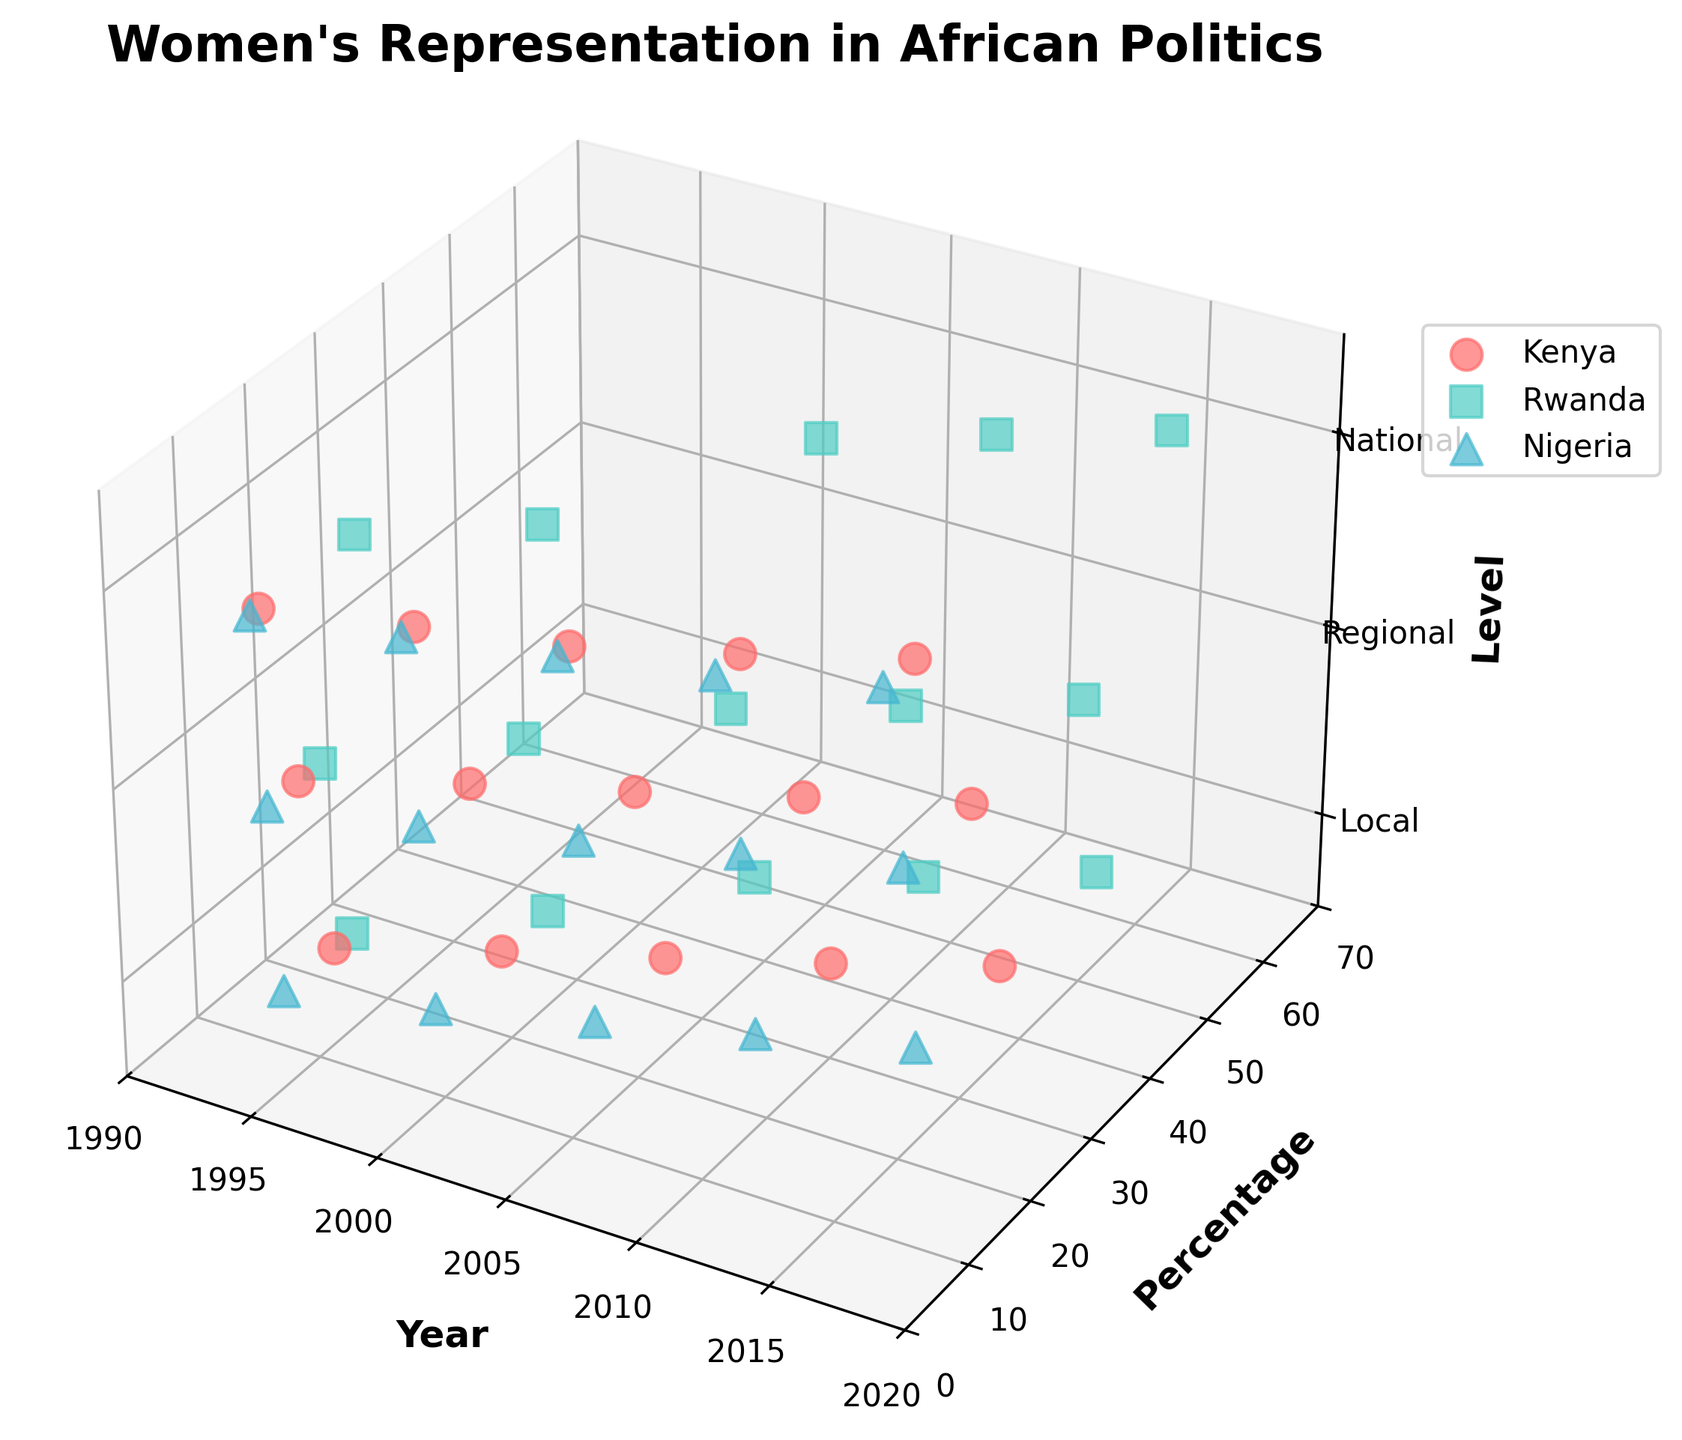What are the countries represented in the 3D scatter plot? To identify the countries in the plot, check the colors and markers, and verify each country labeled in the legend. There are three distinct countries in the legend.
Answer: Kenya, Rwanda, Nigeria What is the title of the 3D scatter plot? The title of the plot is found at the top center of the figure.
Answer: Women's Representation in African Politics Which country has the highest percentage of women's representation at the national level in 2015? Look at the data points for National level (z-axis labeled as National) from 2015 (x-axis). Find the highest percentage value (y-axis) for those points.
Answer: Rwanda How does the percentage of women's representation at the local level in Kenya change over time? Identify the data points for Kenya at the Local level (z-axis labeled as Local). Notice the trend for data points along the x-axis (Year) and y-axis (Percentage). It's an increasing trend.
Answer: Increases Compare the percentage of women's representation in Kenya at the regional level in 2000 and 2015. Which year had a higher percentage? Locate data points for Kenya at the Regional level (z-axis marked as Regional) in the years 2000 and 2015 (x-axis). Compare the y-axis values (Percentage) for these points.
Answer: 2015 Which country shows the most significant improvement in women's representation at the national level from 1995 to 2015? Examine the data points at the National level for each country, compare the percentage increase from 1995 to 2015. Calculate each change and find the largest. Rwanda's increase from 17.1% to 63.8% is the most significant.
Answer: Rwanda What's the y-axis range covered by the data points in the plot? Observe the minimum and maximum values on the y-axis. The plot clearly sets the y-axis range from 0 to 70.
Answer: 0 to 70 How does Rwanda's representation at the national level in 2005 compare with Nigeria's representation at the same level in the same year? Compare the y-axis values for the data points representing Rwanda and Nigeria in 2005 at the National level. Rwanda's point is significantly higher than Nigeria's.
Answer: Rwanda is higher Identify the trend of women's representation in local politics for Nigeria from 1995 to 2015. Observe the data points related to Nigeria at the Local level from 1995 to 2015 along the x-axis (Year) and y-axis (Percentage). The trend is increasing across the years.
Answer: Increasing What is the z-label for the axis representing the different levels of government? The z-label can be seen next to the z-axis of the plot.
Answer: Level 